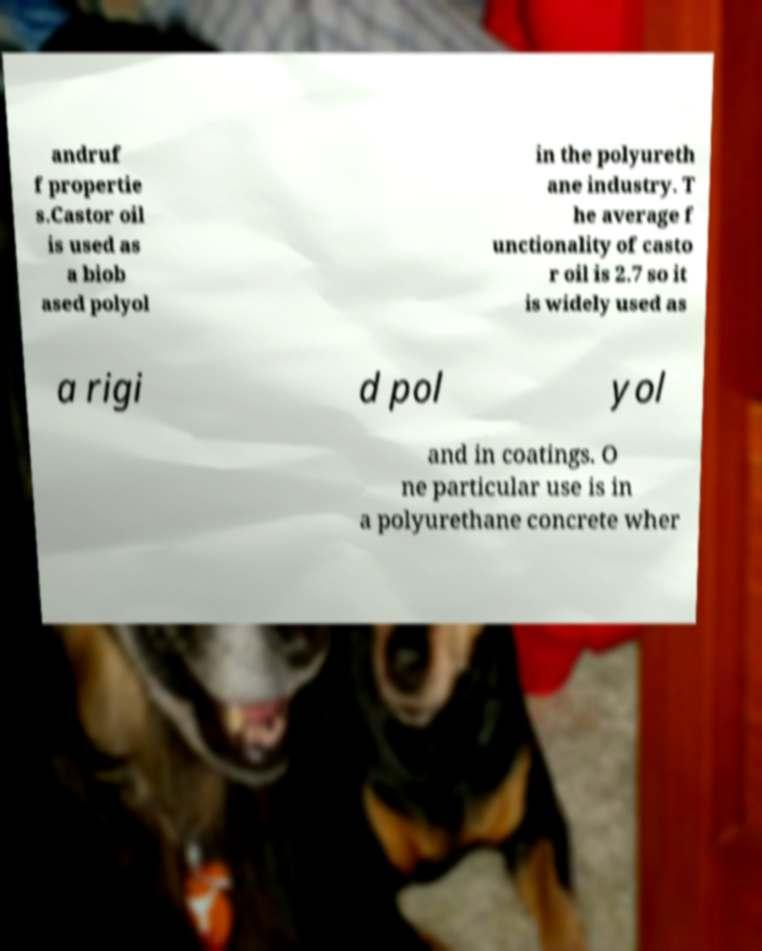For documentation purposes, I need the text within this image transcribed. Could you provide that? andruf f propertie s.Castor oil is used as a biob ased polyol in the polyureth ane industry. T he average f unctionality of casto r oil is 2.7 so it is widely used as a rigi d pol yol and in coatings. O ne particular use is in a polyurethane concrete wher 